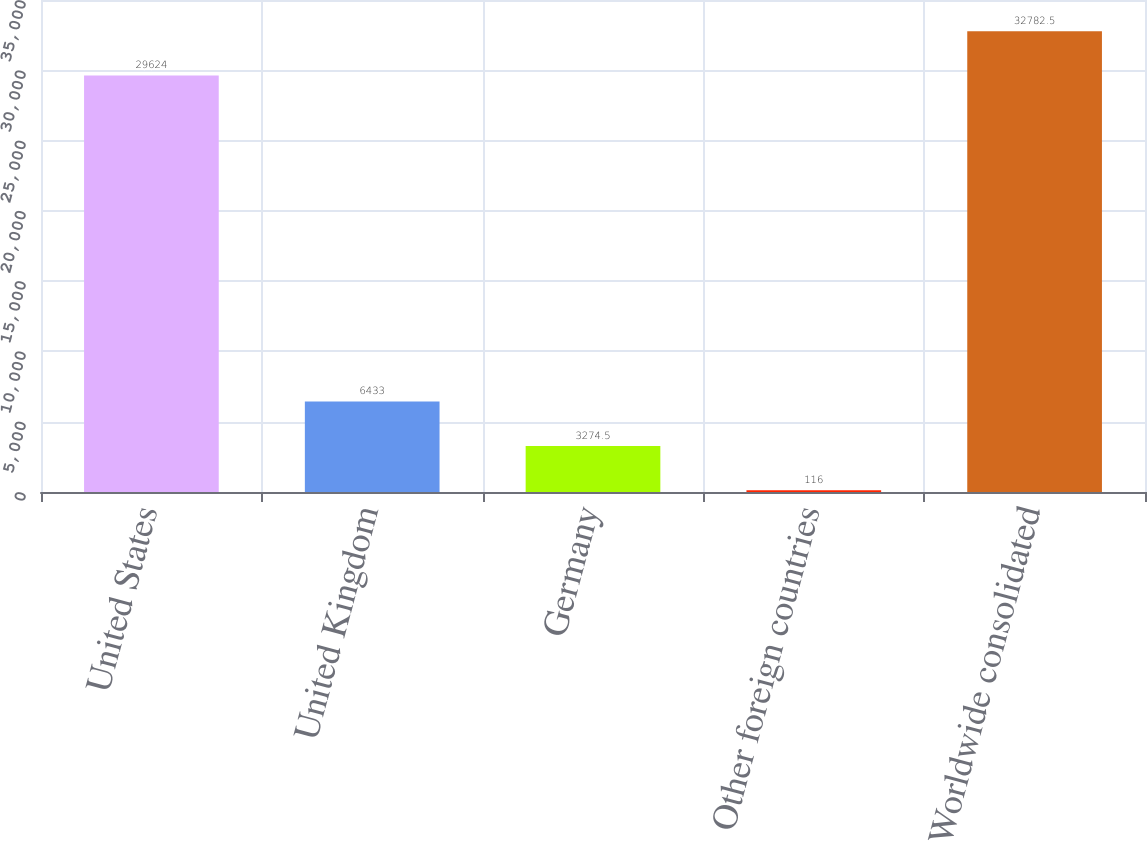<chart> <loc_0><loc_0><loc_500><loc_500><bar_chart><fcel>United States<fcel>United Kingdom<fcel>Germany<fcel>Other foreign countries<fcel>Worldwide consolidated<nl><fcel>29624<fcel>6433<fcel>3274.5<fcel>116<fcel>32782.5<nl></chart> 